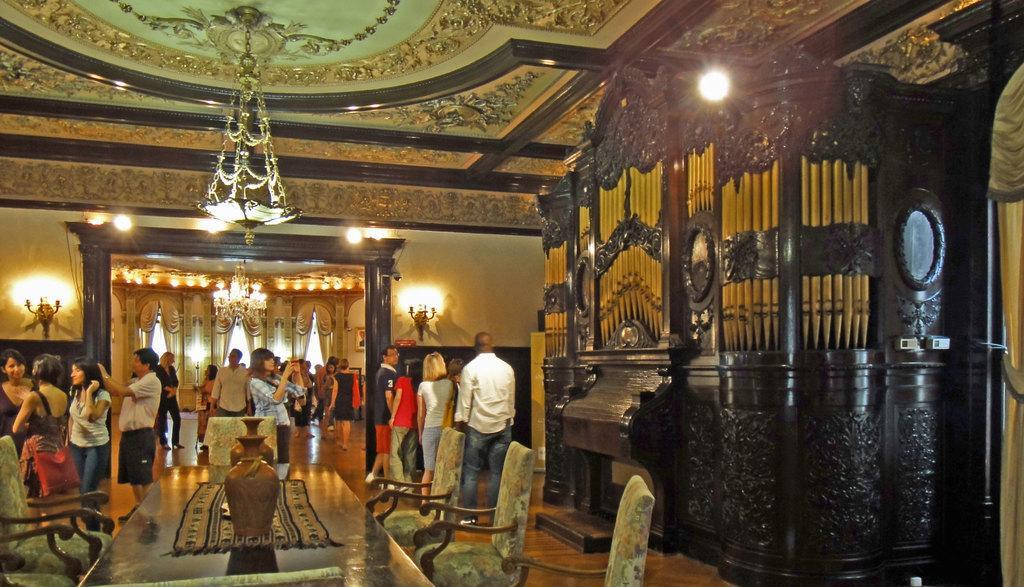In one or two sentences, can you explain what this image depicts? In this image in the center there is a table, on the table there are objects which are brown in colour and there are empty chairs. In the background there are persons standing. On the right side there is a cupboard and there are chandeliers hanging. There are curtains in the background and on the wall there are lights. 